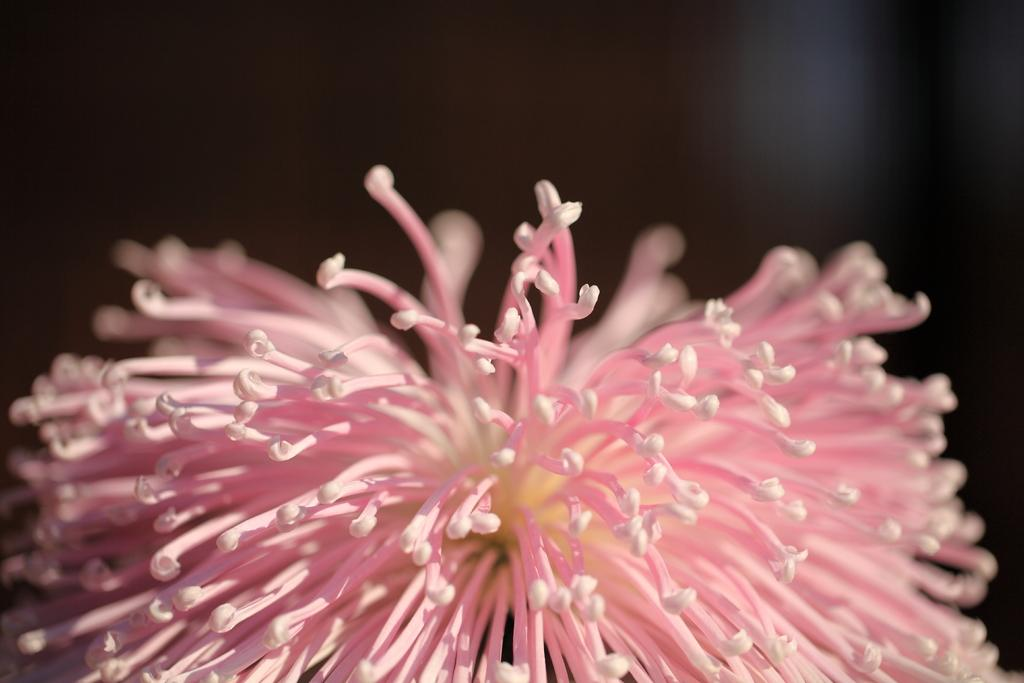What type of flower is in the image? There is a pink color flower in the image. What color is the background of the image? The background of the image is black. What type of magic is being performed with the meat in the image? There is no meat or magic present in the image; it features a pink color flower against a black background. 